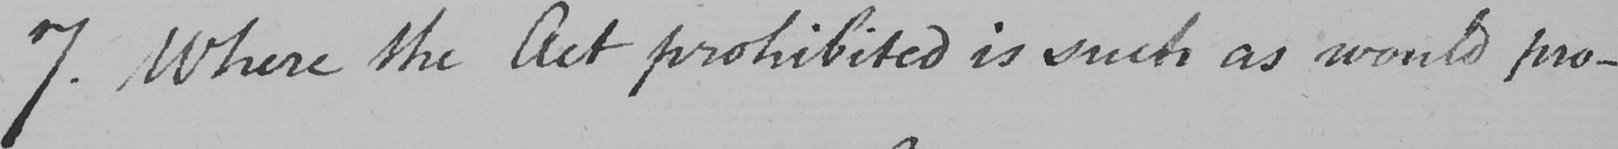Can you read and transcribe this handwriting? 7 . Where the Act prohibited is such as would pro- 